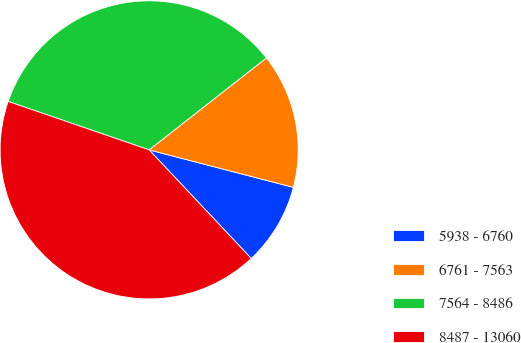Convert chart. <chart><loc_0><loc_0><loc_500><loc_500><pie_chart><fcel>5938 - 6760<fcel>6761 - 7563<fcel>7564 - 8486<fcel>8487 - 13060<nl><fcel>8.94%<fcel>14.63%<fcel>34.15%<fcel>42.28%<nl></chart> 